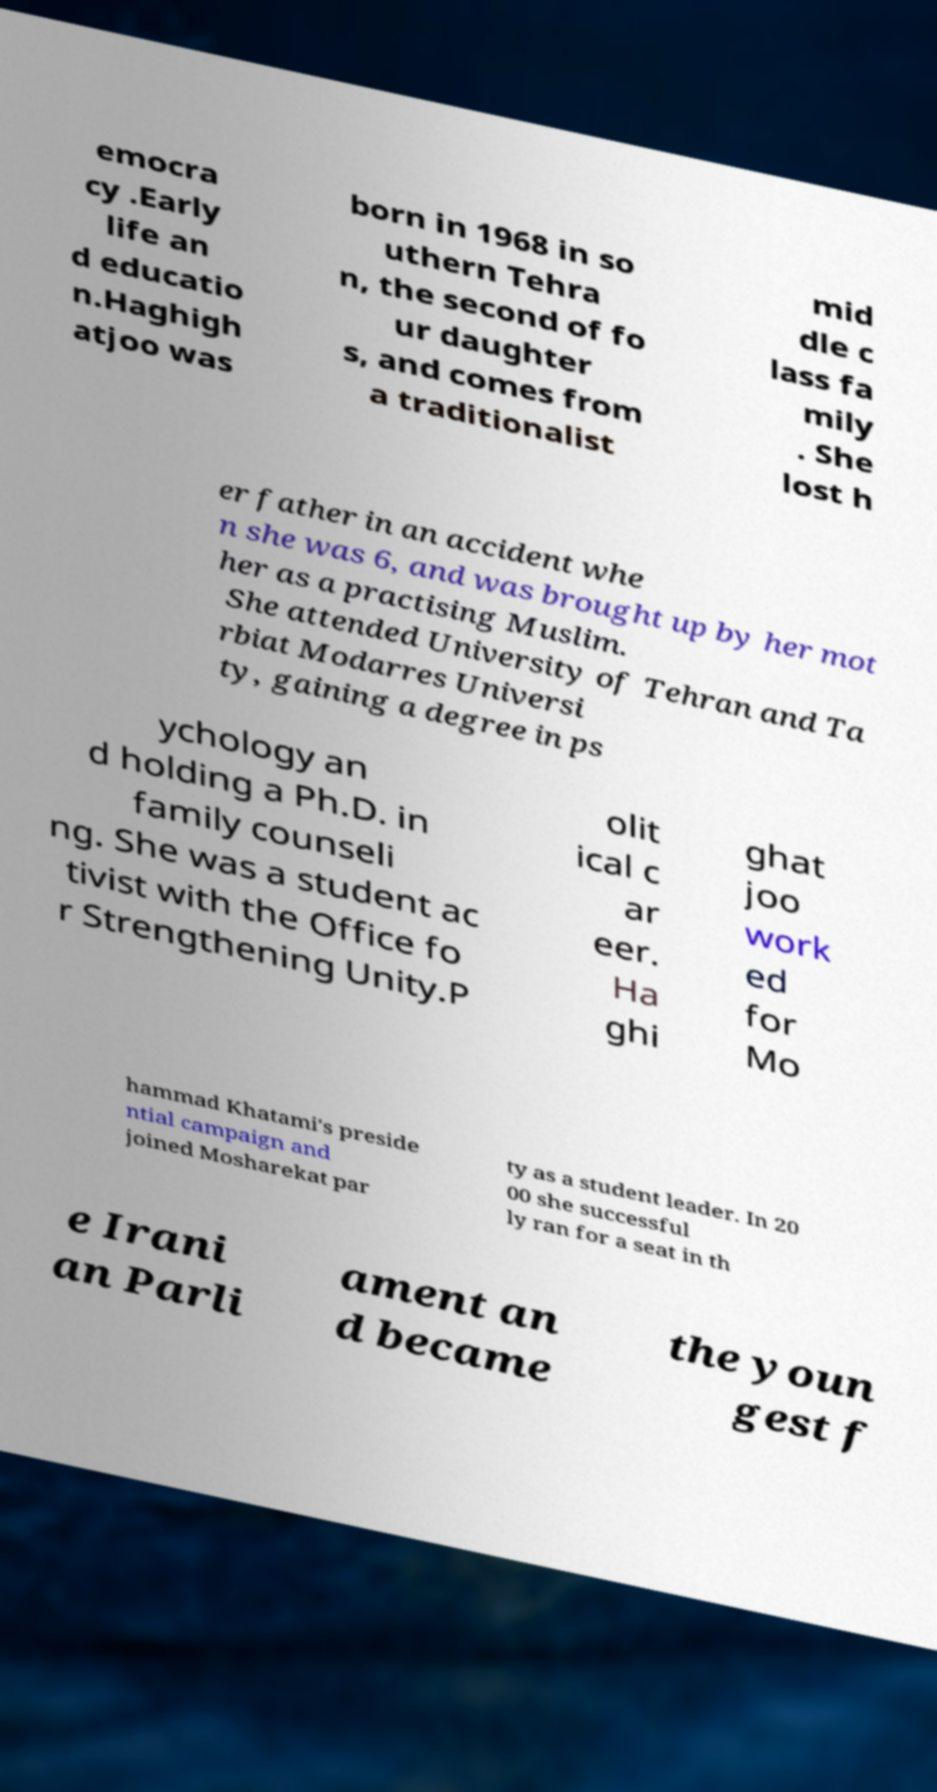For documentation purposes, I need the text within this image transcribed. Could you provide that? emocra cy .Early life an d educatio n.Haghigh atjoo was born in 1968 in so uthern Tehra n, the second of fo ur daughter s, and comes from a traditionalist mid dle c lass fa mily . She lost h er father in an accident whe n she was 6, and was brought up by her mot her as a practising Muslim. She attended University of Tehran and Ta rbiat Modarres Universi ty, gaining a degree in ps ychology an d holding a Ph.D. in family counseli ng. She was a student ac tivist with the Office fo r Strengthening Unity.P olit ical c ar eer. Ha ghi ghat joo work ed for Mo hammad Khatami's preside ntial campaign and joined Mosharekat par ty as a student leader. In 20 00 she successful ly ran for a seat in th e Irani an Parli ament an d became the youn gest f 